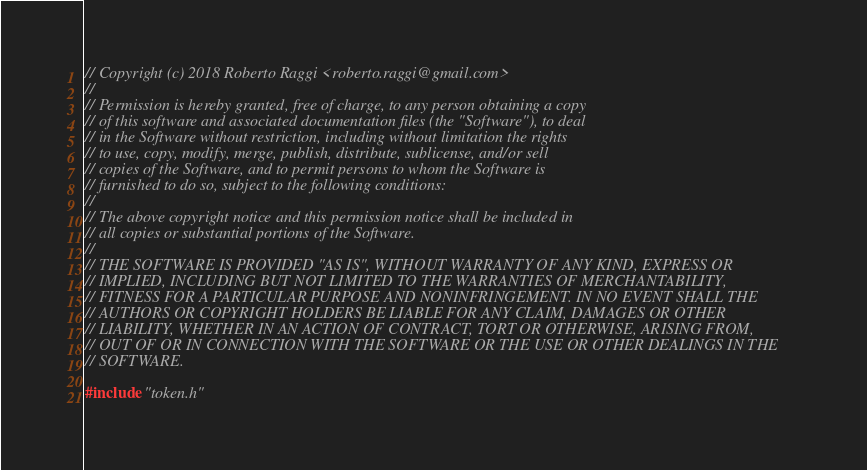Convert code to text. <code><loc_0><loc_0><loc_500><loc_500><_C++_>// Copyright (c) 2018 Roberto Raggi <roberto.raggi@gmail.com>
//
// Permission is hereby granted, free of charge, to any person obtaining a copy
// of this software and associated documentation files (the "Software"), to deal
// in the Software without restriction, including without limitation the rights
// to use, copy, modify, merge, publish, distribute, sublicense, and/or sell
// copies of the Software, and to permit persons to whom the Software is
// furnished to do so, subject to the following conditions:
//
// The above copyright notice and this permission notice shall be included in
// all copies or substantial portions of the Software.
//
// THE SOFTWARE IS PROVIDED "AS IS", WITHOUT WARRANTY OF ANY KIND, EXPRESS OR
// IMPLIED, INCLUDING BUT NOT LIMITED TO THE WARRANTIES OF MERCHANTABILITY,
// FITNESS FOR A PARTICULAR PURPOSE AND NONINFRINGEMENT. IN NO EVENT SHALL THE
// AUTHORS OR COPYRIGHT HOLDERS BE LIABLE FOR ANY CLAIM, DAMAGES OR OTHER
// LIABILITY, WHETHER IN AN ACTION OF CONTRACT, TORT OR OTHERWISE, ARISING FROM,
// OUT OF OR IN CONNECTION WITH THE SOFTWARE OR THE USE OR OTHER DEALINGS IN THE
// SOFTWARE.

#include "token.h"
</code> 